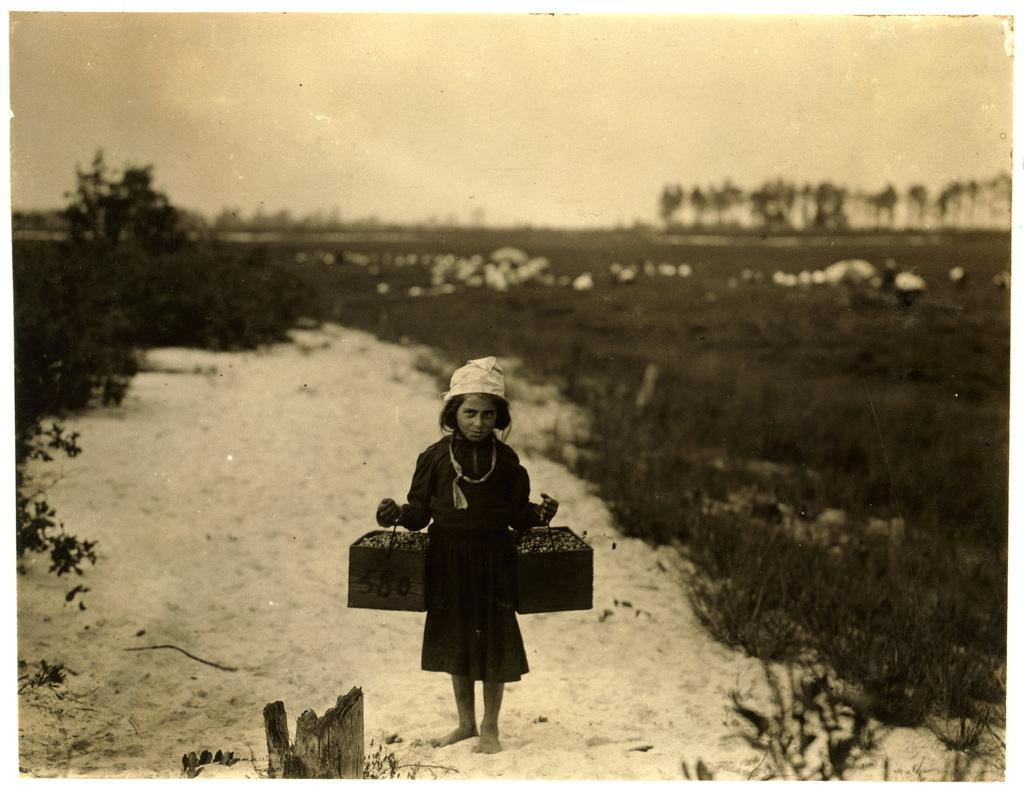Who is the main subject in the picture? There is a girl in the picture. What is the girl holding in the image? The girl is holding two baskets. What is the condition of the ground in the image? The girl is standing on snowy ground. What type of vegetation can be seen in the image? There are trees and plants in the image. Can you see the girl's toes in the image? The image does not show the girl's toes, as her feet are not visible. What type of cork is used to hold the baskets together in the image? There is no cork present in the image, and the baskets are not held together. 